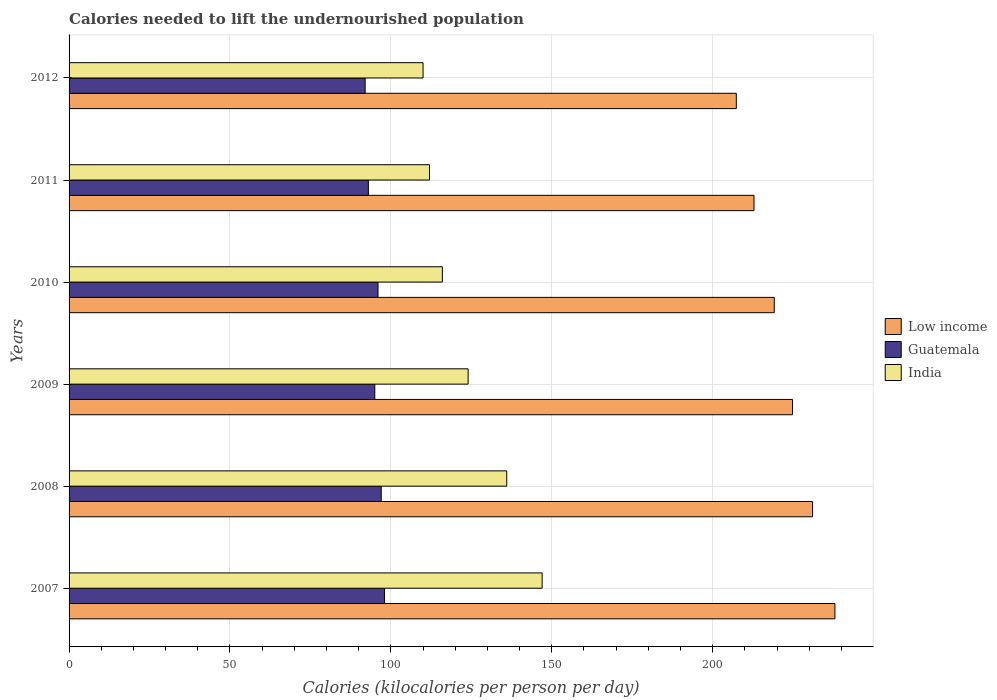Are the number of bars per tick equal to the number of legend labels?
Provide a short and direct response. Yes. Are the number of bars on each tick of the Y-axis equal?
Provide a succinct answer. Yes. How many bars are there on the 3rd tick from the top?
Your answer should be compact. 3. In how many cases, is the number of bars for a given year not equal to the number of legend labels?
Your answer should be very brief. 0. What is the total calories needed to lift the undernourished population in Guatemala in 2010?
Your response must be concise. 96. Across all years, what is the maximum total calories needed to lift the undernourished population in Guatemala?
Your answer should be compact. 98. Across all years, what is the minimum total calories needed to lift the undernourished population in India?
Keep it short and to the point. 110. In which year was the total calories needed to lift the undernourished population in India maximum?
Provide a short and direct response. 2007. What is the total total calories needed to lift the undernourished population in Low income in the graph?
Make the answer very short. 1333.12. What is the difference between the total calories needed to lift the undernourished population in Guatemala in 2008 and that in 2011?
Offer a terse response. 4. What is the difference between the total calories needed to lift the undernourished population in Guatemala in 2009 and the total calories needed to lift the undernourished population in India in 2007?
Provide a succinct answer. -52. What is the average total calories needed to lift the undernourished population in India per year?
Offer a terse response. 124.17. In the year 2008, what is the difference between the total calories needed to lift the undernourished population in Low income and total calories needed to lift the undernourished population in India?
Keep it short and to the point. 95.03. What is the ratio of the total calories needed to lift the undernourished population in India in 2007 to that in 2009?
Your response must be concise. 1.19. Is the total calories needed to lift the undernourished population in Guatemala in 2007 less than that in 2011?
Ensure brevity in your answer.  No. What is the difference between the highest and the second highest total calories needed to lift the undernourished population in Guatemala?
Offer a very short reply. 1. What is the difference between the highest and the lowest total calories needed to lift the undernourished population in Low income?
Make the answer very short. 30.64. In how many years, is the total calories needed to lift the undernourished population in India greater than the average total calories needed to lift the undernourished population in India taken over all years?
Your answer should be compact. 2. Is the sum of the total calories needed to lift the undernourished population in India in 2007 and 2012 greater than the maximum total calories needed to lift the undernourished population in Low income across all years?
Provide a short and direct response. Yes. What does the 2nd bar from the bottom in 2007 represents?
Your response must be concise. Guatemala. Is it the case that in every year, the sum of the total calories needed to lift the undernourished population in Guatemala and total calories needed to lift the undernourished population in India is greater than the total calories needed to lift the undernourished population in Low income?
Provide a succinct answer. No. How many bars are there?
Make the answer very short. 18. Are the values on the major ticks of X-axis written in scientific E-notation?
Provide a short and direct response. No. Does the graph contain grids?
Offer a very short reply. Yes. Where does the legend appear in the graph?
Your response must be concise. Center right. How many legend labels are there?
Provide a short and direct response. 3. How are the legend labels stacked?
Provide a succinct answer. Vertical. What is the title of the graph?
Offer a very short reply. Calories needed to lift the undernourished population. What is the label or title of the X-axis?
Provide a short and direct response. Calories (kilocalories per person per day). What is the Calories (kilocalories per person per day) in Low income in 2007?
Offer a very short reply. 237.98. What is the Calories (kilocalories per person per day) of Guatemala in 2007?
Offer a terse response. 98. What is the Calories (kilocalories per person per day) in India in 2007?
Provide a succinct answer. 147. What is the Calories (kilocalories per person per day) of Low income in 2008?
Your response must be concise. 231.03. What is the Calories (kilocalories per person per day) in Guatemala in 2008?
Offer a very short reply. 97. What is the Calories (kilocalories per person per day) in India in 2008?
Provide a short and direct response. 136. What is the Calories (kilocalories per person per day) of Low income in 2009?
Offer a terse response. 224.81. What is the Calories (kilocalories per person per day) of Guatemala in 2009?
Make the answer very short. 95. What is the Calories (kilocalories per person per day) in India in 2009?
Your answer should be compact. 124. What is the Calories (kilocalories per person per day) in Low income in 2010?
Your answer should be compact. 219.13. What is the Calories (kilocalories per person per day) of Guatemala in 2010?
Your answer should be very brief. 96. What is the Calories (kilocalories per person per day) of India in 2010?
Provide a succinct answer. 116. What is the Calories (kilocalories per person per day) in Low income in 2011?
Your answer should be very brief. 212.84. What is the Calories (kilocalories per person per day) in Guatemala in 2011?
Offer a terse response. 93. What is the Calories (kilocalories per person per day) of India in 2011?
Offer a terse response. 112. What is the Calories (kilocalories per person per day) of Low income in 2012?
Provide a succinct answer. 207.34. What is the Calories (kilocalories per person per day) in Guatemala in 2012?
Keep it short and to the point. 92. What is the Calories (kilocalories per person per day) in India in 2012?
Provide a short and direct response. 110. Across all years, what is the maximum Calories (kilocalories per person per day) of Low income?
Keep it short and to the point. 237.98. Across all years, what is the maximum Calories (kilocalories per person per day) in Guatemala?
Ensure brevity in your answer.  98. Across all years, what is the maximum Calories (kilocalories per person per day) in India?
Your answer should be compact. 147. Across all years, what is the minimum Calories (kilocalories per person per day) of Low income?
Give a very brief answer. 207.34. Across all years, what is the minimum Calories (kilocalories per person per day) of Guatemala?
Offer a very short reply. 92. Across all years, what is the minimum Calories (kilocalories per person per day) of India?
Provide a short and direct response. 110. What is the total Calories (kilocalories per person per day) in Low income in the graph?
Give a very brief answer. 1333.12. What is the total Calories (kilocalories per person per day) of Guatemala in the graph?
Make the answer very short. 571. What is the total Calories (kilocalories per person per day) in India in the graph?
Make the answer very short. 745. What is the difference between the Calories (kilocalories per person per day) in Low income in 2007 and that in 2008?
Offer a very short reply. 6.95. What is the difference between the Calories (kilocalories per person per day) in India in 2007 and that in 2008?
Provide a short and direct response. 11. What is the difference between the Calories (kilocalories per person per day) of Low income in 2007 and that in 2009?
Your response must be concise. 13.17. What is the difference between the Calories (kilocalories per person per day) in Guatemala in 2007 and that in 2009?
Your answer should be very brief. 3. What is the difference between the Calories (kilocalories per person per day) in India in 2007 and that in 2009?
Your response must be concise. 23. What is the difference between the Calories (kilocalories per person per day) of Low income in 2007 and that in 2010?
Make the answer very short. 18.85. What is the difference between the Calories (kilocalories per person per day) of Guatemala in 2007 and that in 2010?
Offer a very short reply. 2. What is the difference between the Calories (kilocalories per person per day) in Low income in 2007 and that in 2011?
Your answer should be very brief. 25.14. What is the difference between the Calories (kilocalories per person per day) of Guatemala in 2007 and that in 2011?
Offer a terse response. 5. What is the difference between the Calories (kilocalories per person per day) of Low income in 2007 and that in 2012?
Provide a short and direct response. 30.64. What is the difference between the Calories (kilocalories per person per day) of Guatemala in 2007 and that in 2012?
Make the answer very short. 6. What is the difference between the Calories (kilocalories per person per day) in India in 2007 and that in 2012?
Make the answer very short. 37. What is the difference between the Calories (kilocalories per person per day) of Low income in 2008 and that in 2009?
Give a very brief answer. 6.22. What is the difference between the Calories (kilocalories per person per day) in India in 2008 and that in 2009?
Provide a succinct answer. 12. What is the difference between the Calories (kilocalories per person per day) of Low income in 2008 and that in 2010?
Your answer should be compact. 11.91. What is the difference between the Calories (kilocalories per person per day) of Low income in 2008 and that in 2011?
Provide a succinct answer. 18.19. What is the difference between the Calories (kilocalories per person per day) of Guatemala in 2008 and that in 2011?
Provide a succinct answer. 4. What is the difference between the Calories (kilocalories per person per day) in India in 2008 and that in 2011?
Keep it short and to the point. 24. What is the difference between the Calories (kilocalories per person per day) in Low income in 2008 and that in 2012?
Provide a succinct answer. 23.69. What is the difference between the Calories (kilocalories per person per day) of Guatemala in 2008 and that in 2012?
Provide a succinct answer. 5. What is the difference between the Calories (kilocalories per person per day) in India in 2008 and that in 2012?
Your answer should be compact. 26. What is the difference between the Calories (kilocalories per person per day) in Low income in 2009 and that in 2010?
Offer a very short reply. 5.68. What is the difference between the Calories (kilocalories per person per day) in Low income in 2009 and that in 2011?
Provide a short and direct response. 11.97. What is the difference between the Calories (kilocalories per person per day) of India in 2009 and that in 2011?
Your answer should be very brief. 12. What is the difference between the Calories (kilocalories per person per day) in Low income in 2009 and that in 2012?
Offer a very short reply. 17.47. What is the difference between the Calories (kilocalories per person per day) in Guatemala in 2009 and that in 2012?
Ensure brevity in your answer.  3. What is the difference between the Calories (kilocalories per person per day) in India in 2009 and that in 2012?
Provide a short and direct response. 14. What is the difference between the Calories (kilocalories per person per day) of Low income in 2010 and that in 2011?
Provide a short and direct response. 6.29. What is the difference between the Calories (kilocalories per person per day) in Guatemala in 2010 and that in 2011?
Give a very brief answer. 3. What is the difference between the Calories (kilocalories per person per day) of Low income in 2010 and that in 2012?
Offer a terse response. 11.79. What is the difference between the Calories (kilocalories per person per day) of India in 2010 and that in 2012?
Provide a succinct answer. 6. What is the difference between the Calories (kilocalories per person per day) of Low income in 2011 and that in 2012?
Your response must be concise. 5.5. What is the difference between the Calories (kilocalories per person per day) in Low income in 2007 and the Calories (kilocalories per person per day) in Guatemala in 2008?
Give a very brief answer. 140.98. What is the difference between the Calories (kilocalories per person per day) of Low income in 2007 and the Calories (kilocalories per person per day) of India in 2008?
Provide a succinct answer. 101.98. What is the difference between the Calories (kilocalories per person per day) in Guatemala in 2007 and the Calories (kilocalories per person per day) in India in 2008?
Offer a very short reply. -38. What is the difference between the Calories (kilocalories per person per day) in Low income in 2007 and the Calories (kilocalories per person per day) in Guatemala in 2009?
Ensure brevity in your answer.  142.98. What is the difference between the Calories (kilocalories per person per day) in Low income in 2007 and the Calories (kilocalories per person per day) in India in 2009?
Your answer should be very brief. 113.98. What is the difference between the Calories (kilocalories per person per day) in Guatemala in 2007 and the Calories (kilocalories per person per day) in India in 2009?
Provide a short and direct response. -26. What is the difference between the Calories (kilocalories per person per day) in Low income in 2007 and the Calories (kilocalories per person per day) in Guatemala in 2010?
Your answer should be very brief. 141.98. What is the difference between the Calories (kilocalories per person per day) of Low income in 2007 and the Calories (kilocalories per person per day) of India in 2010?
Provide a short and direct response. 121.98. What is the difference between the Calories (kilocalories per person per day) in Low income in 2007 and the Calories (kilocalories per person per day) in Guatemala in 2011?
Ensure brevity in your answer.  144.98. What is the difference between the Calories (kilocalories per person per day) of Low income in 2007 and the Calories (kilocalories per person per day) of India in 2011?
Provide a succinct answer. 125.98. What is the difference between the Calories (kilocalories per person per day) of Low income in 2007 and the Calories (kilocalories per person per day) of Guatemala in 2012?
Provide a short and direct response. 145.98. What is the difference between the Calories (kilocalories per person per day) in Low income in 2007 and the Calories (kilocalories per person per day) in India in 2012?
Your response must be concise. 127.98. What is the difference between the Calories (kilocalories per person per day) in Guatemala in 2007 and the Calories (kilocalories per person per day) in India in 2012?
Keep it short and to the point. -12. What is the difference between the Calories (kilocalories per person per day) in Low income in 2008 and the Calories (kilocalories per person per day) in Guatemala in 2009?
Make the answer very short. 136.03. What is the difference between the Calories (kilocalories per person per day) of Low income in 2008 and the Calories (kilocalories per person per day) of India in 2009?
Make the answer very short. 107.03. What is the difference between the Calories (kilocalories per person per day) in Low income in 2008 and the Calories (kilocalories per person per day) in Guatemala in 2010?
Make the answer very short. 135.03. What is the difference between the Calories (kilocalories per person per day) of Low income in 2008 and the Calories (kilocalories per person per day) of India in 2010?
Provide a succinct answer. 115.03. What is the difference between the Calories (kilocalories per person per day) of Low income in 2008 and the Calories (kilocalories per person per day) of Guatemala in 2011?
Make the answer very short. 138.03. What is the difference between the Calories (kilocalories per person per day) in Low income in 2008 and the Calories (kilocalories per person per day) in India in 2011?
Keep it short and to the point. 119.03. What is the difference between the Calories (kilocalories per person per day) in Low income in 2008 and the Calories (kilocalories per person per day) in Guatemala in 2012?
Offer a very short reply. 139.03. What is the difference between the Calories (kilocalories per person per day) in Low income in 2008 and the Calories (kilocalories per person per day) in India in 2012?
Ensure brevity in your answer.  121.03. What is the difference between the Calories (kilocalories per person per day) in Low income in 2009 and the Calories (kilocalories per person per day) in Guatemala in 2010?
Provide a succinct answer. 128.81. What is the difference between the Calories (kilocalories per person per day) of Low income in 2009 and the Calories (kilocalories per person per day) of India in 2010?
Make the answer very short. 108.81. What is the difference between the Calories (kilocalories per person per day) in Guatemala in 2009 and the Calories (kilocalories per person per day) in India in 2010?
Offer a very short reply. -21. What is the difference between the Calories (kilocalories per person per day) in Low income in 2009 and the Calories (kilocalories per person per day) in Guatemala in 2011?
Make the answer very short. 131.81. What is the difference between the Calories (kilocalories per person per day) of Low income in 2009 and the Calories (kilocalories per person per day) of India in 2011?
Give a very brief answer. 112.81. What is the difference between the Calories (kilocalories per person per day) of Low income in 2009 and the Calories (kilocalories per person per day) of Guatemala in 2012?
Give a very brief answer. 132.81. What is the difference between the Calories (kilocalories per person per day) of Low income in 2009 and the Calories (kilocalories per person per day) of India in 2012?
Make the answer very short. 114.81. What is the difference between the Calories (kilocalories per person per day) in Low income in 2010 and the Calories (kilocalories per person per day) in Guatemala in 2011?
Your answer should be very brief. 126.13. What is the difference between the Calories (kilocalories per person per day) in Low income in 2010 and the Calories (kilocalories per person per day) in India in 2011?
Your answer should be very brief. 107.13. What is the difference between the Calories (kilocalories per person per day) of Guatemala in 2010 and the Calories (kilocalories per person per day) of India in 2011?
Your response must be concise. -16. What is the difference between the Calories (kilocalories per person per day) of Low income in 2010 and the Calories (kilocalories per person per day) of Guatemala in 2012?
Your answer should be compact. 127.13. What is the difference between the Calories (kilocalories per person per day) in Low income in 2010 and the Calories (kilocalories per person per day) in India in 2012?
Offer a terse response. 109.13. What is the difference between the Calories (kilocalories per person per day) in Low income in 2011 and the Calories (kilocalories per person per day) in Guatemala in 2012?
Make the answer very short. 120.84. What is the difference between the Calories (kilocalories per person per day) in Low income in 2011 and the Calories (kilocalories per person per day) in India in 2012?
Your answer should be very brief. 102.84. What is the average Calories (kilocalories per person per day) in Low income per year?
Make the answer very short. 222.19. What is the average Calories (kilocalories per person per day) of Guatemala per year?
Your response must be concise. 95.17. What is the average Calories (kilocalories per person per day) in India per year?
Your answer should be very brief. 124.17. In the year 2007, what is the difference between the Calories (kilocalories per person per day) in Low income and Calories (kilocalories per person per day) in Guatemala?
Ensure brevity in your answer.  139.98. In the year 2007, what is the difference between the Calories (kilocalories per person per day) of Low income and Calories (kilocalories per person per day) of India?
Offer a very short reply. 90.98. In the year 2007, what is the difference between the Calories (kilocalories per person per day) in Guatemala and Calories (kilocalories per person per day) in India?
Keep it short and to the point. -49. In the year 2008, what is the difference between the Calories (kilocalories per person per day) in Low income and Calories (kilocalories per person per day) in Guatemala?
Provide a succinct answer. 134.03. In the year 2008, what is the difference between the Calories (kilocalories per person per day) in Low income and Calories (kilocalories per person per day) in India?
Your response must be concise. 95.03. In the year 2008, what is the difference between the Calories (kilocalories per person per day) in Guatemala and Calories (kilocalories per person per day) in India?
Ensure brevity in your answer.  -39. In the year 2009, what is the difference between the Calories (kilocalories per person per day) of Low income and Calories (kilocalories per person per day) of Guatemala?
Offer a terse response. 129.81. In the year 2009, what is the difference between the Calories (kilocalories per person per day) in Low income and Calories (kilocalories per person per day) in India?
Offer a terse response. 100.81. In the year 2010, what is the difference between the Calories (kilocalories per person per day) of Low income and Calories (kilocalories per person per day) of Guatemala?
Keep it short and to the point. 123.13. In the year 2010, what is the difference between the Calories (kilocalories per person per day) in Low income and Calories (kilocalories per person per day) in India?
Offer a terse response. 103.13. In the year 2010, what is the difference between the Calories (kilocalories per person per day) in Guatemala and Calories (kilocalories per person per day) in India?
Your answer should be compact. -20. In the year 2011, what is the difference between the Calories (kilocalories per person per day) in Low income and Calories (kilocalories per person per day) in Guatemala?
Offer a terse response. 119.84. In the year 2011, what is the difference between the Calories (kilocalories per person per day) of Low income and Calories (kilocalories per person per day) of India?
Make the answer very short. 100.84. In the year 2011, what is the difference between the Calories (kilocalories per person per day) of Guatemala and Calories (kilocalories per person per day) of India?
Provide a short and direct response. -19. In the year 2012, what is the difference between the Calories (kilocalories per person per day) in Low income and Calories (kilocalories per person per day) in Guatemala?
Offer a terse response. 115.34. In the year 2012, what is the difference between the Calories (kilocalories per person per day) of Low income and Calories (kilocalories per person per day) of India?
Offer a very short reply. 97.34. What is the ratio of the Calories (kilocalories per person per day) of Low income in 2007 to that in 2008?
Ensure brevity in your answer.  1.03. What is the ratio of the Calories (kilocalories per person per day) in Guatemala in 2007 to that in 2008?
Your response must be concise. 1.01. What is the ratio of the Calories (kilocalories per person per day) in India in 2007 to that in 2008?
Keep it short and to the point. 1.08. What is the ratio of the Calories (kilocalories per person per day) in Low income in 2007 to that in 2009?
Your answer should be very brief. 1.06. What is the ratio of the Calories (kilocalories per person per day) of Guatemala in 2007 to that in 2009?
Keep it short and to the point. 1.03. What is the ratio of the Calories (kilocalories per person per day) of India in 2007 to that in 2009?
Your answer should be compact. 1.19. What is the ratio of the Calories (kilocalories per person per day) in Low income in 2007 to that in 2010?
Provide a short and direct response. 1.09. What is the ratio of the Calories (kilocalories per person per day) of Guatemala in 2007 to that in 2010?
Provide a short and direct response. 1.02. What is the ratio of the Calories (kilocalories per person per day) in India in 2007 to that in 2010?
Your answer should be very brief. 1.27. What is the ratio of the Calories (kilocalories per person per day) in Low income in 2007 to that in 2011?
Your response must be concise. 1.12. What is the ratio of the Calories (kilocalories per person per day) of Guatemala in 2007 to that in 2011?
Offer a terse response. 1.05. What is the ratio of the Calories (kilocalories per person per day) in India in 2007 to that in 2011?
Offer a terse response. 1.31. What is the ratio of the Calories (kilocalories per person per day) of Low income in 2007 to that in 2012?
Your answer should be compact. 1.15. What is the ratio of the Calories (kilocalories per person per day) in Guatemala in 2007 to that in 2012?
Offer a terse response. 1.07. What is the ratio of the Calories (kilocalories per person per day) in India in 2007 to that in 2012?
Provide a succinct answer. 1.34. What is the ratio of the Calories (kilocalories per person per day) in Low income in 2008 to that in 2009?
Your answer should be very brief. 1.03. What is the ratio of the Calories (kilocalories per person per day) of Guatemala in 2008 to that in 2009?
Your answer should be very brief. 1.02. What is the ratio of the Calories (kilocalories per person per day) in India in 2008 to that in 2009?
Your answer should be compact. 1.1. What is the ratio of the Calories (kilocalories per person per day) of Low income in 2008 to that in 2010?
Give a very brief answer. 1.05. What is the ratio of the Calories (kilocalories per person per day) in Guatemala in 2008 to that in 2010?
Keep it short and to the point. 1.01. What is the ratio of the Calories (kilocalories per person per day) in India in 2008 to that in 2010?
Your answer should be very brief. 1.17. What is the ratio of the Calories (kilocalories per person per day) of Low income in 2008 to that in 2011?
Ensure brevity in your answer.  1.09. What is the ratio of the Calories (kilocalories per person per day) in Guatemala in 2008 to that in 2011?
Offer a very short reply. 1.04. What is the ratio of the Calories (kilocalories per person per day) in India in 2008 to that in 2011?
Provide a succinct answer. 1.21. What is the ratio of the Calories (kilocalories per person per day) in Low income in 2008 to that in 2012?
Make the answer very short. 1.11. What is the ratio of the Calories (kilocalories per person per day) in Guatemala in 2008 to that in 2012?
Give a very brief answer. 1.05. What is the ratio of the Calories (kilocalories per person per day) in India in 2008 to that in 2012?
Your answer should be very brief. 1.24. What is the ratio of the Calories (kilocalories per person per day) in Low income in 2009 to that in 2010?
Your response must be concise. 1.03. What is the ratio of the Calories (kilocalories per person per day) of India in 2009 to that in 2010?
Your answer should be very brief. 1.07. What is the ratio of the Calories (kilocalories per person per day) of Low income in 2009 to that in 2011?
Ensure brevity in your answer.  1.06. What is the ratio of the Calories (kilocalories per person per day) in Guatemala in 2009 to that in 2011?
Your response must be concise. 1.02. What is the ratio of the Calories (kilocalories per person per day) of India in 2009 to that in 2011?
Give a very brief answer. 1.11. What is the ratio of the Calories (kilocalories per person per day) of Low income in 2009 to that in 2012?
Your response must be concise. 1.08. What is the ratio of the Calories (kilocalories per person per day) of Guatemala in 2009 to that in 2012?
Your answer should be very brief. 1.03. What is the ratio of the Calories (kilocalories per person per day) in India in 2009 to that in 2012?
Give a very brief answer. 1.13. What is the ratio of the Calories (kilocalories per person per day) in Low income in 2010 to that in 2011?
Ensure brevity in your answer.  1.03. What is the ratio of the Calories (kilocalories per person per day) of Guatemala in 2010 to that in 2011?
Your answer should be very brief. 1.03. What is the ratio of the Calories (kilocalories per person per day) in India in 2010 to that in 2011?
Your response must be concise. 1.04. What is the ratio of the Calories (kilocalories per person per day) of Low income in 2010 to that in 2012?
Provide a short and direct response. 1.06. What is the ratio of the Calories (kilocalories per person per day) of Guatemala in 2010 to that in 2012?
Offer a terse response. 1.04. What is the ratio of the Calories (kilocalories per person per day) of India in 2010 to that in 2012?
Offer a very short reply. 1.05. What is the ratio of the Calories (kilocalories per person per day) of Low income in 2011 to that in 2012?
Give a very brief answer. 1.03. What is the ratio of the Calories (kilocalories per person per day) in Guatemala in 2011 to that in 2012?
Keep it short and to the point. 1.01. What is the ratio of the Calories (kilocalories per person per day) of India in 2011 to that in 2012?
Ensure brevity in your answer.  1.02. What is the difference between the highest and the second highest Calories (kilocalories per person per day) of Low income?
Keep it short and to the point. 6.95. What is the difference between the highest and the second highest Calories (kilocalories per person per day) of Guatemala?
Ensure brevity in your answer.  1. What is the difference between the highest and the second highest Calories (kilocalories per person per day) of India?
Provide a succinct answer. 11. What is the difference between the highest and the lowest Calories (kilocalories per person per day) in Low income?
Make the answer very short. 30.64. What is the difference between the highest and the lowest Calories (kilocalories per person per day) in India?
Your answer should be compact. 37. 